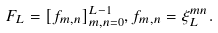<formula> <loc_0><loc_0><loc_500><loc_500>F _ { L } = [ f _ { m , n } ] _ { m , n = 0 } ^ { L - 1 } , f _ { m , n } = \xi ^ { m n } _ { L } .</formula> 